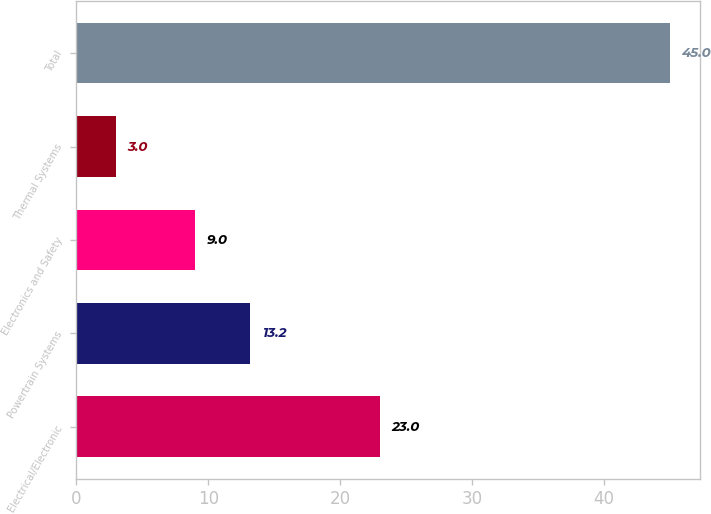<chart> <loc_0><loc_0><loc_500><loc_500><bar_chart><fcel>Electrical/Electronic<fcel>Powertrain Systems<fcel>Electronics and Safety<fcel>Thermal Systems<fcel>Total<nl><fcel>23<fcel>13.2<fcel>9<fcel>3<fcel>45<nl></chart> 